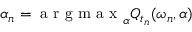<formula> <loc_0><loc_0><loc_500><loc_500>\alpha _ { n } = \arg \max _ { \alpha } Q _ { t _ { n } } ( \omega _ { n } , \alpha )</formula> 